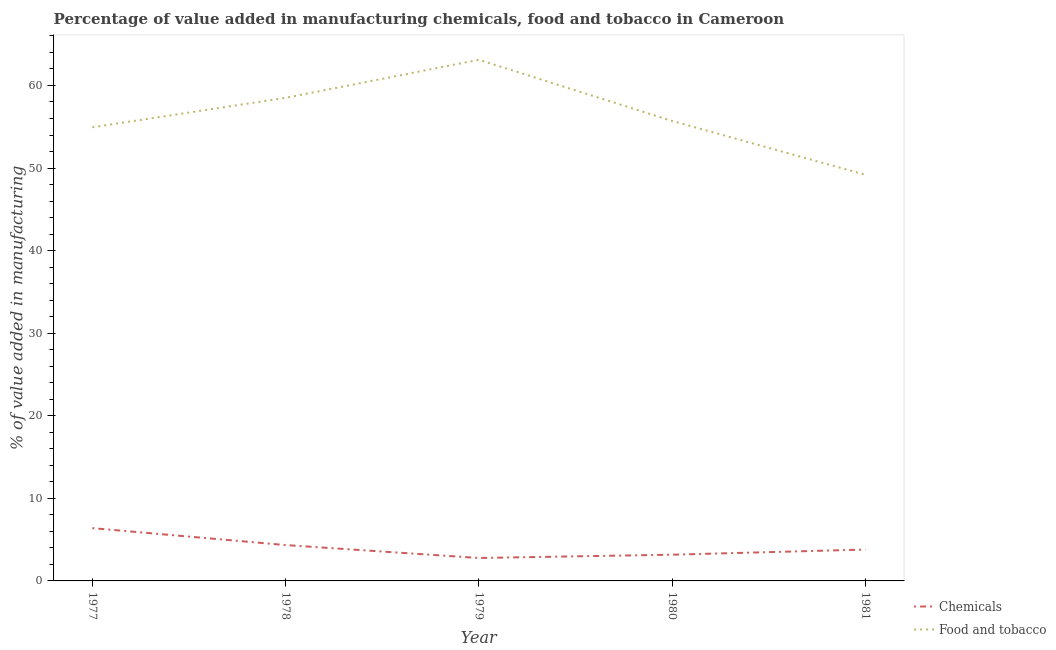How many different coloured lines are there?
Make the answer very short. 2. What is the value added by  manufacturing chemicals in 1981?
Make the answer very short. 3.8. Across all years, what is the maximum value added by manufacturing food and tobacco?
Give a very brief answer. 63.11. Across all years, what is the minimum value added by manufacturing food and tobacco?
Offer a very short reply. 49.19. In which year was the value added by manufacturing food and tobacco minimum?
Offer a very short reply. 1981. What is the total value added by manufacturing food and tobacco in the graph?
Give a very brief answer. 281.44. What is the difference between the value added by manufacturing food and tobacco in 1978 and that in 1979?
Ensure brevity in your answer.  -4.61. What is the difference between the value added by manufacturing food and tobacco in 1981 and the value added by  manufacturing chemicals in 1979?
Keep it short and to the point. 46.41. What is the average value added by manufacturing food and tobacco per year?
Offer a very short reply. 56.29. In the year 1980, what is the difference between the value added by manufacturing food and tobacco and value added by  manufacturing chemicals?
Provide a short and direct response. 52.53. In how many years, is the value added by manufacturing food and tobacco greater than 22 %?
Keep it short and to the point. 5. What is the ratio of the value added by manufacturing food and tobacco in 1977 to that in 1981?
Ensure brevity in your answer.  1.12. Is the difference between the value added by  manufacturing chemicals in 1978 and 1979 greater than the difference between the value added by manufacturing food and tobacco in 1978 and 1979?
Offer a very short reply. Yes. What is the difference between the highest and the second highest value added by  manufacturing chemicals?
Provide a succinct answer. 2.05. What is the difference between the highest and the lowest value added by  manufacturing chemicals?
Keep it short and to the point. 3.62. In how many years, is the value added by  manufacturing chemicals greater than the average value added by  manufacturing chemicals taken over all years?
Offer a terse response. 2. Does the value added by manufacturing food and tobacco monotonically increase over the years?
Offer a very short reply. No. How many years are there in the graph?
Provide a succinct answer. 5. Are the values on the major ticks of Y-axis written in scientific E-notation?
Offer a very short reply. No. Does the graph contain grids?
Provide a succinct answer. No. Where does the legend appear in the graph?
Offer a terse response. Bottom right. How many legend labels are there?
Ensure brevity in your answer.  2. What is the title of the graph?
Keep it short and to the point. Percentage of value added in manufacturing chemicals, food and tobacco in Cameroon. Does "Methane emissions" appear as one of the legend labels in the graph?
Keep it short and to the point. No. What is the label or title of the X-axis?
Your answer should be compact. Year. What is the label or title of the Y-axis?
Provide a short and direct response. % of value added in manufacturing. What is the % of value added in manufacturing of Chemicals in 1977?
Ensure brevity in your answer.  6.39. What is the % of value added in manufacturing in Food and tobacco in 1977?
Offer a very short reply. 54.94. What is the % of value added in manufacturing of Chemicals in 1978?
Ensure brevity in your answer.  4.34. What is the % of value added in manufacturing of Food and tobacco in 1978?
Offer a terse response. 58.5. What is the % of value added in manufacturing in Chemicals in 1979?
Make the answer very short. 2.78. What is the % of value added in manufacturing in Food and tobacco in 1979?
Offer a terse response. 63.11. What is the % of value added in manufacturing of Chemicals in 1980?
Your response must be concise. 3.18. What is the % of value added in manufacturing of Food and tobacco in 1980?
Provide a succinct answer. 55.7. What is the % of value added in manufacturing of Chemicals in 1981?
Your response must be concise. 3.8. What is the % of value added in manufacturing of Food and tobacco in 1981?
Your answer should be very brief. 49.19. Across all years, what is the maximum % of value added in manufacturing in Chemicals?
Ensure brevity in your answer.  6.39. Across all years, what is the maximum % of value added in manufacturing in Food and tobacco?
Your answer should be very brief. 63.11. Across all years, what is the minimum % of value added in manufacturing of Chemicals?
Provide a short and direct response. 2.78. Across all years, what is the minimum % of value added in manufacturing in Food and tobacco?
Provide a succinct answer. 49.19. What is the total % of value added in manufacturing in Chemicals in the graph?
Offer a terse response. 20.48. What is the total % of value added in manufacturing of Food and tobacco in the graph?
Offer a terse response. 281.44. What is the difference between the % of value added in manufacturing in Chemicals in 1977 and that in 1978?
Ensure brevity in your answer.  2.05. What is the difference between the % of value added in manufacturing in Food and tobacco in 1977 and that in 1978?
Offer a very short reply. -3.57. What is the difference between the % of value added in manufacturing of Chemicals in 1977 and that in 1979?
Your response must be concise. 3.62. What is the difference between the % of value added in manufacturing in Food and tobacco in 1977 and that in 1979?
Give a very brief answer. -8.17. What is the difference between the % of value added in manufacturing of Chemicals in 1977 and that in 1980?
Give a very brief answer. 3.22. What is the difference between the % of value added in manufacturing of Food and tobacco in 1977 and that in 1980?
Make the answer very short. -0.77. What is the difference between the % of value added in manufacturing of Chemicals in 1977 and that in 1981?
Ensure brevity in your answer.  2.59. What is the difference between the % of value added in manufacturing in Food and tobacco in 1977 and that in 1981?
Ensure brevity in your answer.  5.75. What is the difference between the % of value added in manufacturing in Chemicals in 1978 and that in 1979?
Your answer should be compact. 1.57. What is the difference between the % of value added in manufacturing of Food and tobacco in 1978 and that in 1979?
Provide a short and direct response. -4.61. What is the difference between the % of value added in manufacturing of Chemicals in 1978 and that in 1980?
Your answer should be very brief. 1.17. What is the difference between the % of value added in manufacturing in Food and tobacco in 1978 and that in 1980?
Give a very brief answer. 2.8. What is the difference between the % of value added in manufacturing of Chemicals in 1978 and that in 1981?
Keep it short and to the point. 0.54. What is the difference between the % of value added in manufacturing in Food and tobacco in 1978 and that in 1981?
Provide a succinct answer. 9.32. What is the difference between the % of value added in manufacturing in Chemicals in 1979 and that in 1980?
Your answer should be very brief. -0.4. What is the difference between the % of value added in manufacturing in Food and tobacco in 1979 and that in 1980?
Make the answer very short. 7.41. What is the difference between the % of value added in manufacturing in Chemicals in 1979 and that in 1981?
Give a very brief answer. -1.02. What is the difference between the % of value added in manufacturing in Food and tobacco in 1979 and that in 1981?
Your answer should be compact. 13.92. What is the difference between the % of value added in manufacturing of Chemicals in 1980 and that in 1981?
Your response must be concise. -0.62. What is the difference between the % of value added in manufacturing of Food and tobacco in 1980 and that in 1981?
Give a very brief answer. 6.52. What is the difference between the % of value added in manufacturing in Chemicals in 1977 and the % of value added in manufacturing in Food and tobacco in 1978?
Offer a very short reply. -52.11. What is the difference between the % of value added in manufacturing of Chemicals in 1977 and the % of value added in manufacturing of Food and tobacco in 1979?
Your answer should be very brief. -56.72. What is the difference between the % of value added in manufacturing in Chemicals in 1977 and the % of value added in manufacturing in Food and tobacco in 1980?
Offer a very short reply. -49.31. What is the difference between the % of value added in manufacturing in Chemicals in 1977 and the % of value added in manufacturing in Food and tobacco in 1981?
Your response must be concise. -42.8. What is the difference between the % of value added in manufacturing in Chemicals in 1978 and the % of value added in manufacturing in Food and tobacco in 1979?
Provide a succinct answer. -58.77. What is the difference between the % of value added in manufacturing in Chemicals in 1978 and the % of value added in manufacturing in Food and tobacco in 1980?
Provide a short and direct response. -51.36. What is the difference between the % of value added in manufacturing of Chemicals in 1978 and the % of value added in manufacturing of Food and tobacco in 1981?
Your answer should be compact. -44.85. What is the difference between the % of value added in manufacturing in Chemicals in 1979 and the % of value added in manufacturing in Food and tobacco in 1980?
Your answer should be compact. -52.93. What is the difference between the % of value added in manufacturing in Chemicals in 1979 and the % of value added in manufacturing in Food and tobacco in 1981?
Offer a very short reply. -46.41. What is the difference between the % of value added in manufacturing in Chemicals in 1980 and the % of value added in manufacturing in Food and tobacco in 1981?
Give a very brief answer. -46.01. What is the average % of value added in manufacturing of Chemicals per year?
Offer a terse response. 4.1. What is the average % of value added in manufacturing of Food and tobacco per year?
Your answer should be very brief. 56.29. In the year 1977, what is the difference between the % of value added in manufacturing of Chemicals and % of value added in manufacturing of Food and tobacco?
Provide a short and direct response. -48.55. In the year 1978, what is the difference between the % of value added in manufacturing of Chemicals and % of value added in manufacturing of Food and tobacco?
Make the answer very short. -54.16. In the year 1979, what is the difference between the % of value added in manufacturing in Chemicals and % of value added in manufacturing in Food and tobacco?
Provide a short and direct response. -60.33. In the year 1980, what is the difference between the % of value added in manufacturing in Chemicals and % of value added in manufacturing in Food and tobacco?
Make the answer very short. -52.53. In the year 1981, what is the difference between the % of value added in manufacturing of Chemicals and % of value added in manufacturing of Food and tobacco?
Offer a terse response. -45.39. What is the ratio of the % of value added in manufacturing of Chemicals in 1977 to that in 1978?
Ensure brevity in your answer.  1.47. What is the ratio of the % of value added in manufacturing of Food and tobacco in 1977 to that in 1978?
Your answer should be very brief. 0.94. What is the ratio of the % of value added in manufacturing of Chemicals in 1977 to that in 1979?
Your response must be concise. 2.3. What is the ratio of the % of value added in manufacturing of Food and tobacco in 1977 to that in 1979?
Your answer should be very brief. 0.87. What is the ratio of the % of value added in manufacturing in Chemicals in 1977 to that in 1980?
Ensure brevity in your answer.  2.01. What is the ratio of the % of value added in manufacturing in Food and tobacco in 1977 to that in 1980?
Your response must be concise. 0.99. What is the ratio of the % of value added in manufacturing in Chemicals in 1977 to that in 1981?
Make the answer very short. 1.68. What is the ratio of the % of value added in manufacturing of Food and tobacco in 1977 to that in 1981?
Ensure brevity in your answer.  1.12. What is the ratio of the % of value added in manufacturing of Chemicals in 1978 to that in 1979?
Offer a terse response. 1.56. What is the ratio of the % of value added in manufacturing of Food and tobacco in 1978 to that in 1979?
Provide a short and direct response. 0.93. What is the ratio of the % of value added in manufacturing in Chemicals in 1978 to that in 1980?
Make the answer very short. 1.37. What is the ratio of the % of value added in manufacturing in Food and tobacco in 1978 to that in 1980?
Provide a succinct answer. 1.05. What is the ratio of the % of value added in manufacturing of Chemicals in 1978 to that in 1981?
Offer a very short reply. 1.14. What is the ratio of the % of value added in manufacturing in Food and tobacco in 1978 to that in 1981?
Ensure brevity in your answer.  1.19. What is the ratio of the % of value added in manufacturing of Chemicals in 1979 to that in 1980?
Offer a very short reply. 0.87. What is the ratio of the % of value added in manufacturing of Food and tobacco in 1979 to that in 1980?
Provide a succinct answer. 1.13. What is the ratio of the % of value added in manufacturing of Chemicals in 1979 to that in 1981?
Give a very brief answer. 0.73. What is the ratio of the % of value added in manufacturing in Food and tobacco in 1979 to that in 1981?
Provide a succinct answer. 1.28. What is the ratio of the % of value added in manufacturing of Chemicals in 1980 to that in 1981?
Make the answer very short. 0.84. What is the ratio of the % of value added in manufacturing in Food and tobacco in 1980 to that in 1981?
Your answer should be compact. 1.13. What is the difference between the highest and the second highest % of value added in manufacturing of Chemicals?
Offer a very short reply. 2.05. What is the difference between the highest and the second highest % of value added in manufacturing of Food and tobacco?
Your answer should be compact. 4.61. What is the difference between the highest and the lowest % of value added in manufacturing in Chemicals?
Give a very brief answer. 3.62. What is the difference between the highest and the lowest % of value added in manufacturing of Food and tobacco?
Give a very brief answer. 13.92. 